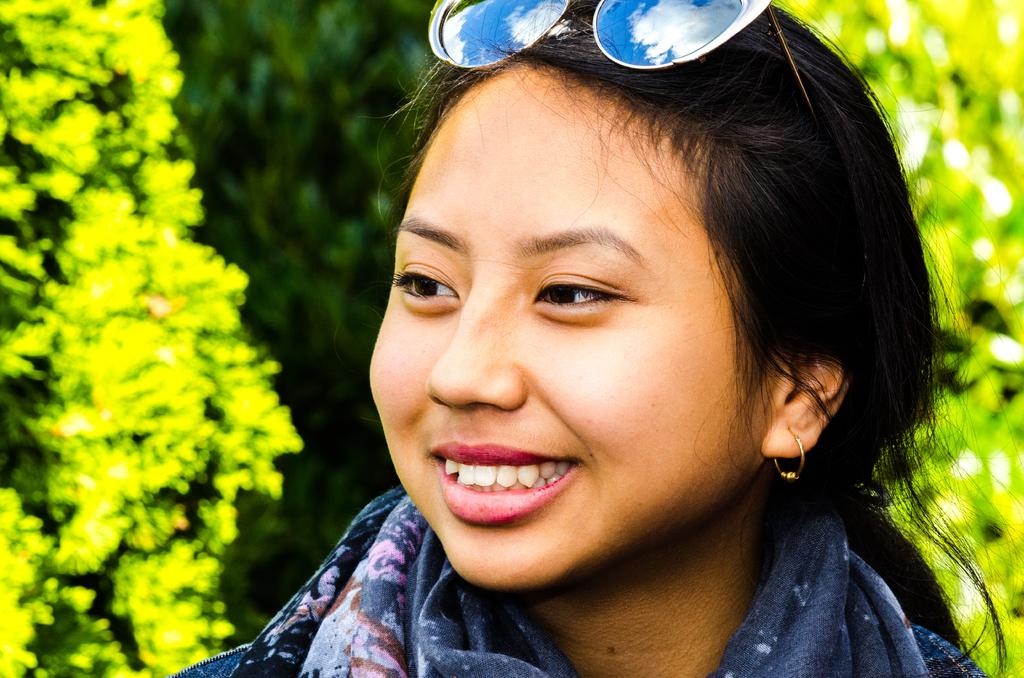Who is the main subject in the foreground of the image? There is a woman in the foreground of the image. What is the woman wearing on her face? The woman is wearing goggles. What type of natural environment can be seen in the background of the image? There are trees in the background of the image. What type of plantation can be seen in the image? There is no plantation present in the image; it features a woman wearing goggles with trees in the background. 